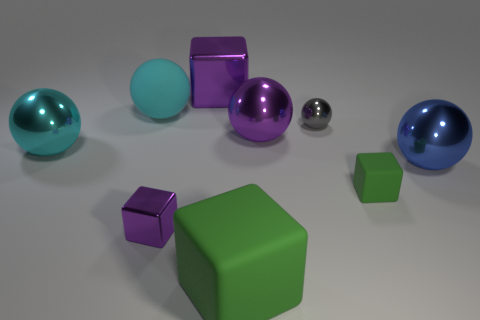What is the big purple ball made of?
Provide a short and direct response. Metal. There is a metallic object that is in front of the small green thing; how big is it?
Offer a very short reply. Small. Are there any other things that have the same color as the tiny shiny ball?
Keep it short and to the point. No. Are there any purple objects that are behind the green cube in front of the small metal object that is in front of the blue ball?
Provide a short and direct response. Yes. There is a small shiny object left of the purple sphere; is it the same color as the tiny shiny ball?
Make the answer very short. No. How many balls are tiny objects or cyan objects?
Your answer should be very brief. 3. There is a purple object right of the large cube in front of the small gray shiny ball; what is its shape?
Make the answer very short. Sphere. What size is the shiny cube that is in front of the matte thing that is behind the big purple thing that is to the right of the large purple cube?
Your answer should be compact. Small. Does the cyan matte sphere have the same size as the blue ball?
Make the answer very short. Yes. What number of things are either large shiny objects or large cyan metal things?
Provide a short and direct response. 4. 